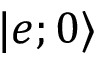Convert formula to latex. <formula><loc_0><loc_0><loc_500><loc_500>| e ; 0 \rangle</formula> 